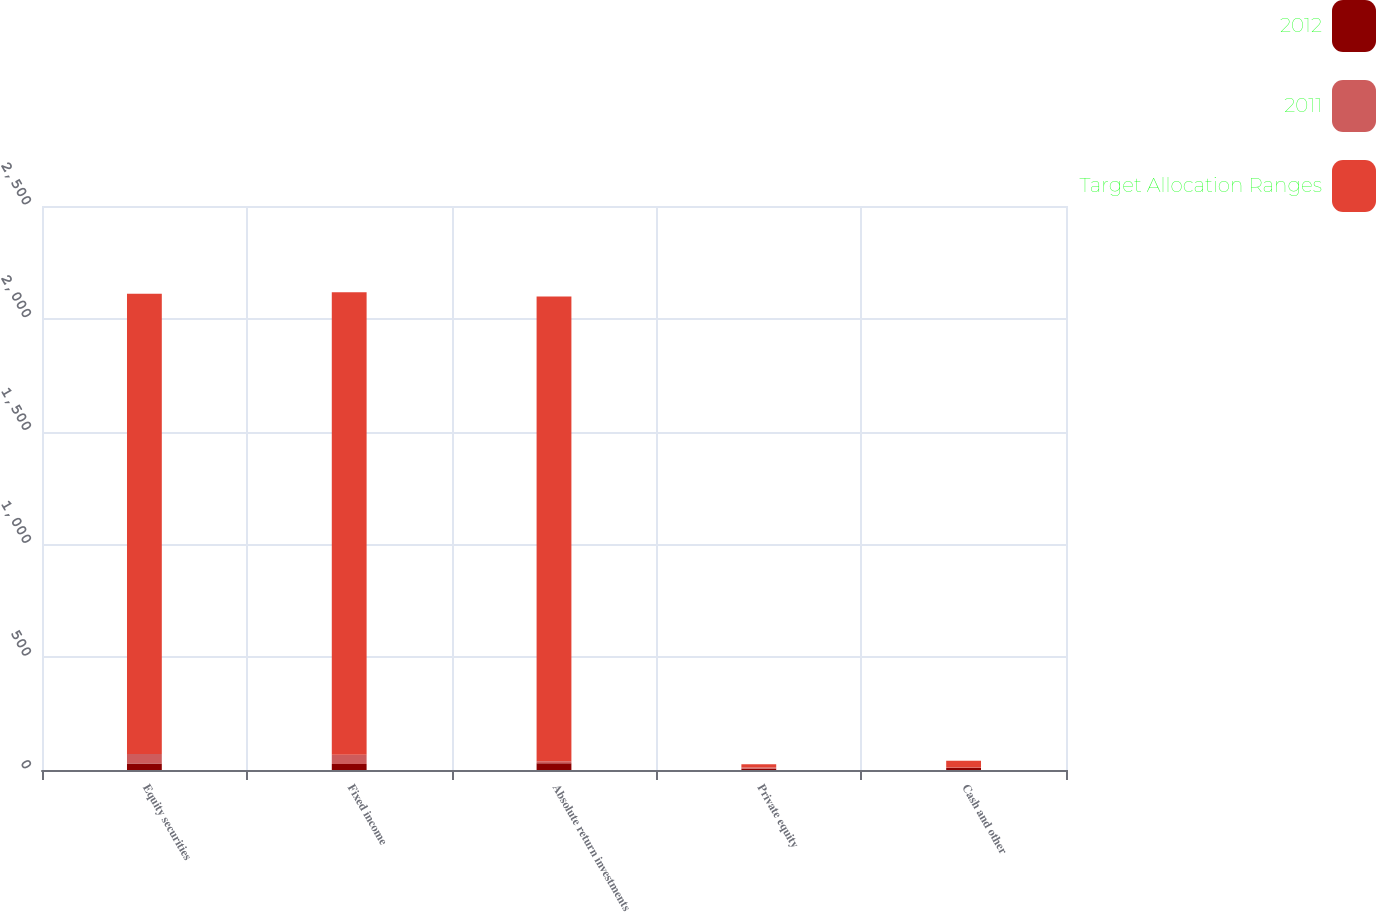Convert chart. <chart><loc_0><loc_0><loc_500><loc_500><stacked_bar_chart><ecel><fcel>Equity securities<fcel>Fixed income<fcel>Absolute return investments<fcel>Private equity<fcel>Cash and other<nl><fcel>2012<fcel>29.2<fcel>26.4<fcel>29.4<fcel>5.1<fcel>9.9<nl><fcel>2011<fcel>42.2<fcel>41.5<fcel>8.9<fcel>5.8<fcel>1.6<nl><fcel>Target Allocation Ranges<fcel>2040<fcel>2050<fcel>2060<fcel>15<fcel>30<nl></chart> 